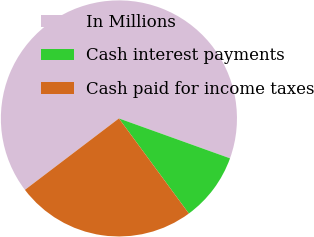Convert chart. <chart><loc_0><loc_0><loc_500><loc_500><pie_chart><fcel>In Millions<fcel>Cash interest payments<fcel>Cash paid for income taxes<nl><fcel>65.83%<fcel>9.42%<fcel>24.75%<nl></chart> 